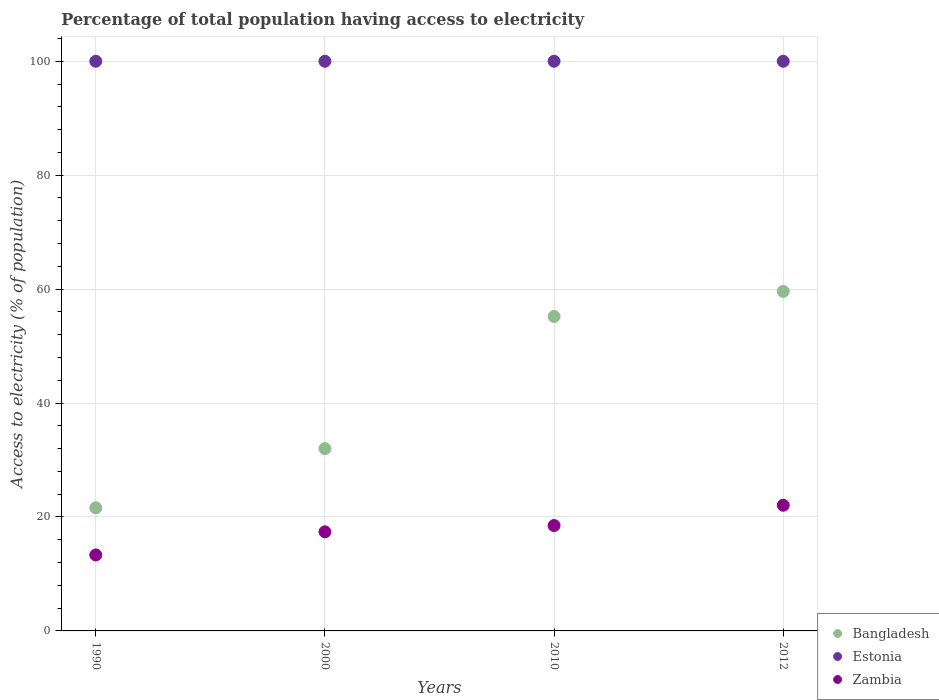What is the percentage of population that have access to electricity in Bangladesh in 2000?
Keep it short and to the point. 32. Across all years, what is the maximum percentage of population that have access to electricity in Bangladesh?
Your answer should be very brief. 59.6. Across all years, what is the minimum percentage of population that have access to electricity in Zambia?
Offer a very short reply. 13.34. In which year was the percentage of population that have access to electricity in Zambia maximum?
Your response must be concise. 2012. What is the total percentage of population that have access to electricity in Zambia in the graph?
Ensure brevity in your answer.  71.3. What is the difference between the percentage of population that have access to electricity in Zambia in 2010 and the percentage of population that have access to electricity in Estonia in 2012?
Provide a succinct answer. -81.5. What is the average percentage of population that have access to electricity in Zambia per year?
Provide a succinct answer. 17.83. In the year 2010, what is the difference between the percentage of population that have access to electricity in Estonia and percentage of population that have access to electricity in Zambia?
Offer a terse response. 81.5. What is the ratio of the percentage of population that have access to electricity in Estonia in 1990 to that in 2012?
Ensure brevity in your answer.  1. What is the difference between the highest and the second highest percentage of population that have access to electricity in Estonia?
Your answer should be compact. 0. How many dotlines are there?
Keep it short and to the point. 3. How many years are there in the graph?
Ensure brevity in your answer.  4. Does the graph contain grids?
Your response must be concise. Yes. Where does the legend appear in the graph?
Ensure brevity in your answer.  Bottom right. How are the legend labels stacked?
Your answer should be compact. Vertical. What is the title of the graph?
Offer a terse response. Percentage of total population having access to electricity. Does "Kosovo" appear as one of the legend labels in the graph?
Offer a terse response. No. What is the label or title of the Y-axis?
Ensure brevity in your answer.  Access to electricity (% of population). What is the Access to electricity (% of population) in Bangladesh in 1990?
Make the answer very short. 21.62. What is the Access to electricity (% of population) of Estonia in 1990?
Offer a terse response. 100. What is the Access to electricity (% of population) of Zambia in 1990?
Your answer should be very brief. 13.34. What is the Access to electricity (% of population) in Zambia in 2000?
Your answer should be compact. 17.4. What is the Access to electricity (% of population) of Bangladesh in 2010?
Ensure brevity in your answer.  55.2. What is the Access to electricity (% of population) in Estonia in 2010?
Your answer should be very brief. 100. What is the Access to electricity (% of population) of Bangladesh in 2012?
Offer a very short reply. 59.6. What is the Access to electricity (% of population) of Zambia in 2012?
Provide a succinct answer. 22.06. Across all years, what is the maximum Access to electricity (% of population) of Bangladesh?
Give a very brief answer. 59.6. Across all years, what is the maximum Access to electricity (% of population) of Zambia?
Provide a succinct answer. 22.06. Across all years, what is the minimum Access to electricity (% of population) in Bangladesh?
Provide a succinct answer. 21.62. Across all years, what is the minimum Access to electricity (% of population) of Estonia?
Provide a short and direct response. 100. Across all years, what is the minimum Access to electricity (% of population) of Zambia?
Make the answer very short. 13.34. What is the total Access to electricity (% of population) of Bangladesh in the graph?
Offer a terse response. 168.42. What is the total Access to electricity (% of population) of Zambia in the graph?
Provide a short and direct response. 71.3. What is the difference between the Access to electricity (% of population) of Bangladesh in 1990 and that in 2000?
Offer a very short reply. -10.38. What is the difference between the Access to electricity (% of population) of Estonia in 1990 and that in 2000?
Provide a short and direct response. 0. What is the difference between the Access to electricity (% of population) in Zambia in 1990 and that in 2000?
Offer a very short reply. -4.06. What is the difference between the Access to electricity (% of population) of Bangladesh in 1990 and that in 2010?
Offer a terse response. -33.58. What is the difference between the Access to electricity (% of population) of Zambia in 1990 and that in 2010?
Your answer should be compact. -5.16. What is the difference between the Access to electricity (% of population) in Bangladesh in 1990 and that in 2012?
Offer a terse response. -37.98. What is the difference between the Access to electricity (% of population) of Estonia in 1990 and that in 2012?
Your response must be concise. 0. What is the difference between the Access to electricity (% of population) in Zambia in 1990 and that in 2012?
Provide a succinct answer. -8.72. What is the difference between the Access to electricity (% of population) in Bangladesh in 2000 and that in 2010?
Ensure brevity in your answer.  -23.2. What is the difference between the Access to electricity (% of population) in Zambia in 2000 and that in 2010?
Provide a succinct answer. -1.1. What is the difference between the Access to electricity (% of population) of Bangladesh in 2000 and that in 2012?
Keep it short and to the point. -27.6. What is the difference between the Access to electricity (% of population) of Estonia in 2000 and that in 2012?
Offer a terse response. 0. What is the difference between the Access to electricity (% of population) of Zambia in 2000 and that in 2012?
Offer a terse response. -4.66. What is the difference between the Access to electricity (% of population) in Zambia in 2010 and that in 2012?
Ensure brevity in your answer.  -3.56. What is the difference between the Access to electricity (% of population) of Bangladesh in 1990 and the Access to electricity (% of population) of Estonia in 2000?
Provide a short and direct response. -78.38. What is the difference between the Access to electricity (% of population) of Bangladesh in 1990 and the Access to electricity (% of population) of Zambia in 2000?
Ensure brevity in your answer.  4.22. What is the difference between the Access to electricity (% of population) of Estonia in 1990 and the Access to electricity (% of population) of Zambia in 2000?
Ensure brevity in your answer.  82.6. What is the difference between the Access to electricity (% of population) of Bangladesh in 1990 and the Access to electricity (% of population) of Estonia in 2010?
Keep it short and to the point. -78.38. What is the difference between the Access to electricity (% of population) in Bangladesh in 1990 and the Access to electricity (% of population) in Zambia in 2010?
Give a very brief answer. 3.12. What is the difference between the Access to electricity (% of population) of Estonia in 1990 and the Access to electricity (% of population) of Zambia in 2010?
Your answer should be compact. 81.5. What is the difference between the Access to electricity (% of population) of Bangladesh in 1990 and the Access to electricity (% of population) of Estonia in 2012?
Your answer should be very brief. -78.38. What is the difference between the Access to electricity (% of population) in Bangladesh in 1990 and the Access to electricity (% of population) in Zambia in 2012?
Offer a terse response. -0.44. What is the difference between the Access to electricity (% of population) in Estonia in 1990 and the Access to electricity (% of population) in Zambia in 2012?
Your answer should be very brief. 77.94. What is the difference between the Access to electricity (% of population) in Bangladesh in 2000 and the Access to electricity (% of population) in Estonia in 2010?
Ensure brevity in your answer.  -68. What is the difference between the Access to electricity (% of population) in Estonia in 2000 and the Access to electricity (% of population) in Zambia in 2010?
Give a very brief answer. 81.5. What is the difference between the Access to electricity (% of population) of Bangladesh in 2000 and the Access to electricity (% of population) of Estonia in 2012?
Offer a very short reply. -68. What is the difference between the Access to electricity (% of population) in Bangladesh in 2000 and the Access to electricity (% of population) in Zambia in 2012?
Your answer should be compact. 9.94. What is the difference between the Access to electricity (% of population) of Estonia in 2000 and the Access to electricity (% of population) of Zambia in 2012?
Make the answer very short. 77.94. What is the difference between the Access to electricity (% of population) in Bangladesh in 2010 and the Access to electricity (% of population) in Estonia in 2012?
Ensure brevity in your answer.  -44.8. What is the difference between the Access to electricity (% of population) in Bangladesh in 2010 and the Access to electricity (% of population) in Zambia in 2012?
Keep it short and to the point. 33.14. What is the difference between the Access to electricity (% of population) in Estonia in 2010 and the Access to electricity (% of population) in Zambia in 2012?
Your response must be concise. 77.94. What is the average Access to electricity (% of population) of Bangladesh per year?
Provide a succinct answer. 42.1. What is the average Access to electricity (% of population) in Estonia per year?
Your response must be concise. 100. What is the average Access to electricity (% of population) in Zambia per year?
Offer a very short reply. 17.83. In the year 1990, what is the difference between the Access to electricity (% of population) of Bangladesh and Access to electricity (% of population) of Estonia?
Your response must be concise. -78.38. In the year 1990, what is the difference between the Access to electricity (% of population) in Bangladesh and Access to electricity (% of population) in Zambia?
Offer a terse response. 8.28. In the year 1990, what is the difference between the Access to electricity (% of population) of Estonia and Access to electricity (% of population) of Zambia?
Provide a short and direct response. 86.66. In the year 2000, what is the difference between the Access to electricity (% of population) of Bangladesh and Access to electricity (% of population) of Estonia?
Ensure brevity in your answer.  -68. In the year 2000, what is the difference between the Access to electricity (% of population) of Bangladesh and Access to electricity (% of population) of Zambia?
Your answer should be compact. 14.6. In the year 2000, what is the difference between the Access to electricity (% of population) in Estonia and Access to electricity (% of population) in Zambia?
Keep it short and to the point. 82.6. In the year 2010, what is the difference between the Access to electricity (% of population) of Bangladesh and Access to electricity (% of population) of Estonia?
Give a very brief answer. -44.8. In the year 2010, what is the difference between the Access to electricity (% of population) in Bangladesh and Access to electricity (% of population) in Zambia?
Your response must be concise. 36.7. In the year 2010, what is the difference between the Access to electricity (% of population) of Estonia and Access to electricity (% of population) of Zambia?
Offer a terse response. 81.5. In the year 2012, what is the difference between the Access to electricity (% of population) of Bangladesh and Access to electricity (% of population) of Estonia?
Offer a very short reply. -40.4. In the year 2012, what is the difference between the Access to electricity (% of population) in Bangladesh and Access to electricity (% of population) in Zambia?
Make the answer very short. 37.54. In the year 2012, what is the difference between the Access to electricity (% of population) of Estonia and Access to electricity (% of population) of Zambia?
Give a very brief answer. 77.94. What is the ratio of the Access to electricity (% of population) of Bangladesh in 1990 to that in 2000?
Provide a succinct answer. 0.68. What is the ratio of the Access to electricity (% of population) in Zambia in 1990 to that in 2000?
Provide a succinct answer. 0.77. What is the ratio of the Access to electricity (% of population) of Bangladesh in 1990 to that in 2010?
Give a very brief answer. 0.39. What is the ratio of the Access to electricity (% of population) of Zambia in 1990 to that in 2010?
Provide a succinct answer. 0.72. What is the ratio of the Access to electricity (% of population) in Bangladesh in 1990 to that in 2012?
Your response must be concise. 0.36. What is the ratio of the Access to electricity (% of population) of Estonia in 1990 to that in 2012?
Provide a succinct answer. 1. What is the ratio of the Access to electricity (% of population) of Zambia in 1990 to that in 2012?
Give a very brief answer. 0.6. What is the ratio of the Access to electricity (% of population) of Bangladesh in 2000 to that in 2010?
Your response must be concise. 0.58. What is the ratio of the Access to electricity (% of population) in Zambia in 2000 to that in 2010?
Make the answer very short. 0.94. What is the ratio of the Access to electricity (% of population) in Bangladesh in 2000 to that in 2012?
Make the answer very short. 0.54. What is the ratio of the Access to electricity (% of population) of Zambia in 2000 to that in 2012?
Give a very brief answer. 0.79. What is the ratio of the Access to electricity (% of population) of Bangladesh in 2010 to that in 2012?
Provide a short and direct response. 0.93. What is the ratio of the Access to electricity (% of population) of Zambia in 2010 to that in 2012?
Your answer should be very brief. 0.84. What is the difference between the highest and the second highest Access to electricity (% of population) of Bangladesh?
Offer a very short reply. 4.4. What is the difference between the highest and the second highest Access to electricity (% of population) in Zambia?
Your answer should be compact. 3.56. What is the difference between the highest and the lowest Access to electricity (% of population) in Bangladesh?
Your answer should be very brief. 37.98. What is the difference between the highest and the lowest Access to electricity (% of population) in Zambia?
Provide a short and direct response. 8.72. 